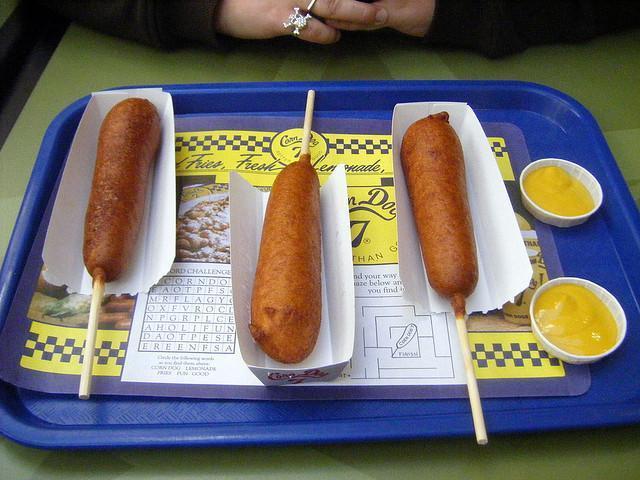How many mustards are here?
Give a very brief answer. 2. How many corn dogs are facing the camera?
Give a very brief answer. 1. How many bowls are in the picture?
Give a very brief answer. 2. How many hot dogs are in the photo?
Give a very brief answer. 3. 